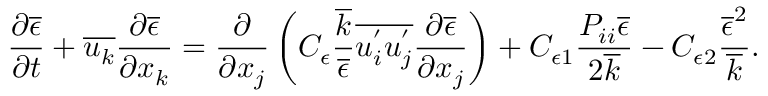<formula> <loc_0><loc_0><loc_500><loc_500>\frac { \partial \overline { \epsilon } } { \partial t } + \overline { { u _ { k } } } \frac { \partial \overline { \epsilon } } { \partial x _ { k } } = \frac { \partial } { \partial x _ { j } } \left ( C _ { \epsilon } \frac { \overline { k } } { \overline { \epsilon } } \overline { { u _ { i } ^ { ^ { \prime } } u _ { j } ^ { ^ { \prime } } } } \frac { \partial \overline { \epsilon } } { \partial x _ { j } } \right ) + C _ { \epsilon 1 } \frac { P _ { i i } \overline { \epsilon } } { 2 \overline { k } } - C _ { \epsilon 2 } \frac { \overline { \epsilon } ^ { 2 } } { \overline { k } } .</formula> 